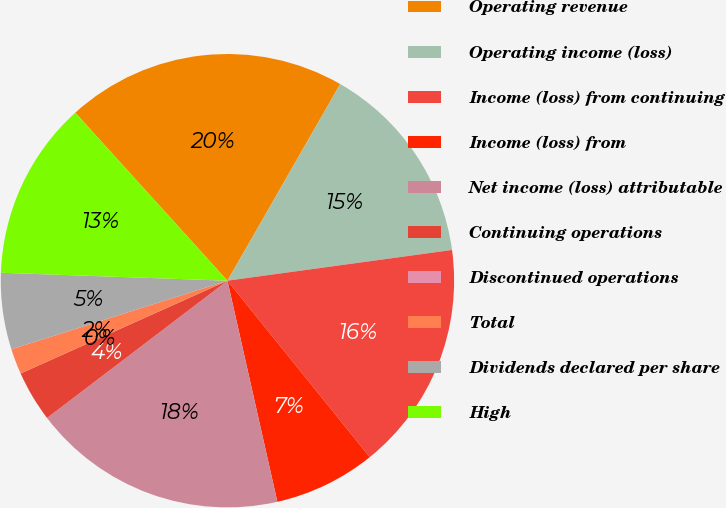Convert chart. <chart><loc_0><loc_0><loc_500><loc_500><pie_chart><fcel>Operating revenue<fcel>Operating income (loss)<fcel>Income (loss) from continuing<fcel>Income (loss) from<fcel>Net income (loss) attributable<fcel>Continuing operations<fcel>Discontinued operations<fcel>Total<fcel>Dividends declared per share<fcel>High<nl><fcel>20.0%<fcel>14.55%<fcel>16.36%<fcel>7.27%<fcel>18.18%<fcel>3.64%<fcel>0.0%<fcel>1.82%<fcel>5.45%<fcel>12.73%<nl></chart> 